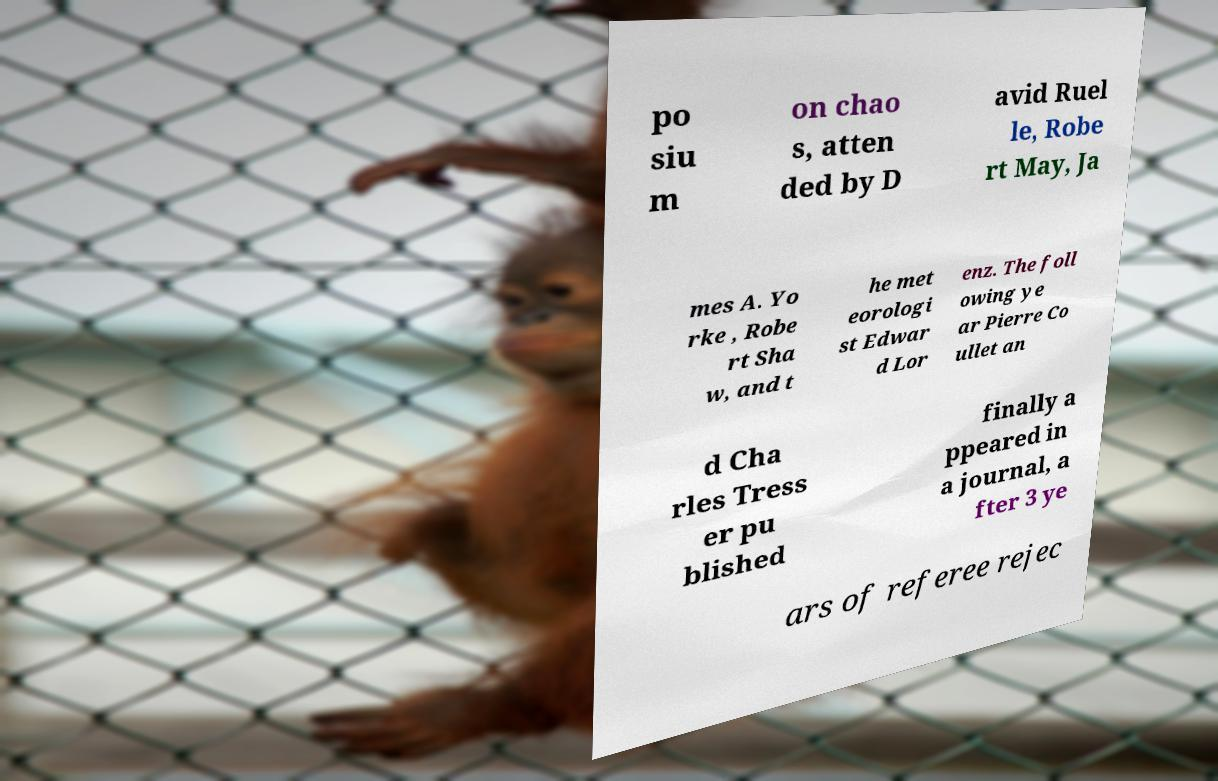Could you extract and type out the text from this image? po siu m on chao s, atten ded by D avid Ruel le, Robe rt May, Ja mes A. Yo rke , Robe rt Sha w, and t he met eorologi st Edwar d Lor enz. The foll owing ye ar Pierre Co ullet an d Cha rles Tress er pu blished finally a ppeared in a journal, a fter 3 ye ars of referee rejec 